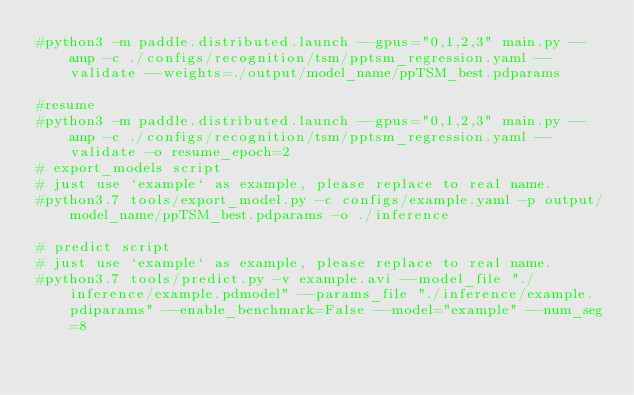<code> <loc_0><loc_0><loc_500><loc_500><_Bash_>#python3 -m paddle.distributed.launch --gpus="0,1,2,3" main.py --amp -c ./configs/recognition/tsm/pptsm_regression.yaml --validate --weights=./output/model_name/ppTSM_best.pdparams

#resume
#python3 -m paddle.distributed.launch --gpus="0,1,2,3" main.py --amp -c ./configs/recognition/tsm/pptsm_regression.yaml --validate -o resume_epoch=2
# export_models script
# just use `example` as example, please replace to real name.
#python3.7 tools/export_model.py -c configs/example.yaml -p output/model_name/ppTSM_best.pdparams -o ./inference

# predict script
# just use `example` as example, please replace to real name.
#python3.7 tools/predict.py -v example.avi --model_file "./inference/example.pdmodel" --params_file "./inference/example.pdiparams" --enable_benchmark=False --model="example" --num_seg=8
</code> 